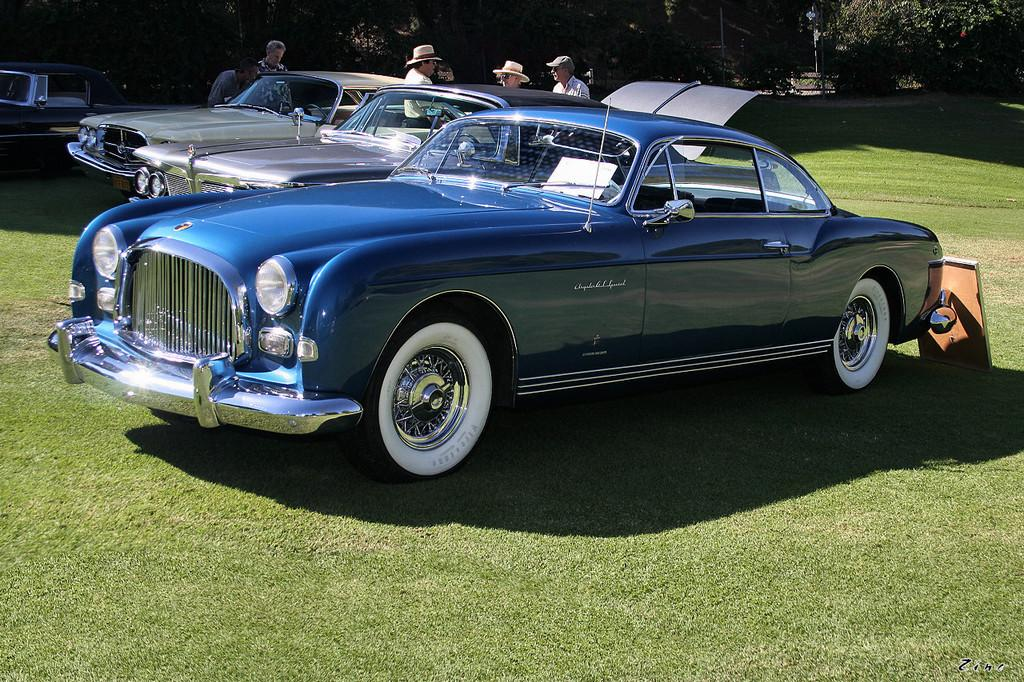How many cars are visible in the image? There are three cars in the image. Where are the cars located? The cars are parked in a parking area. What can be seen in the background of the image? There are trees, plants, and grass in the background of the image. Are there any people present in the image? Yes, there are people standing near the cars. What type of steel is used to construct the icicles hanging from the cars in the image? There are no icicles present in the image, and therefore no steel construction can be observed. 